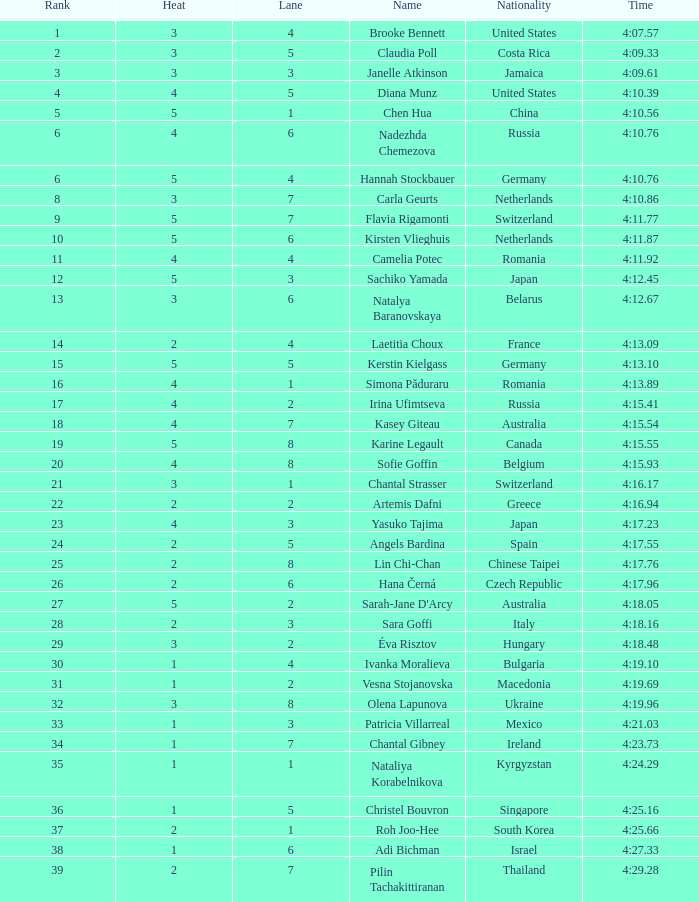Name the least lane for kasey giteau and rank less than 18 None. 